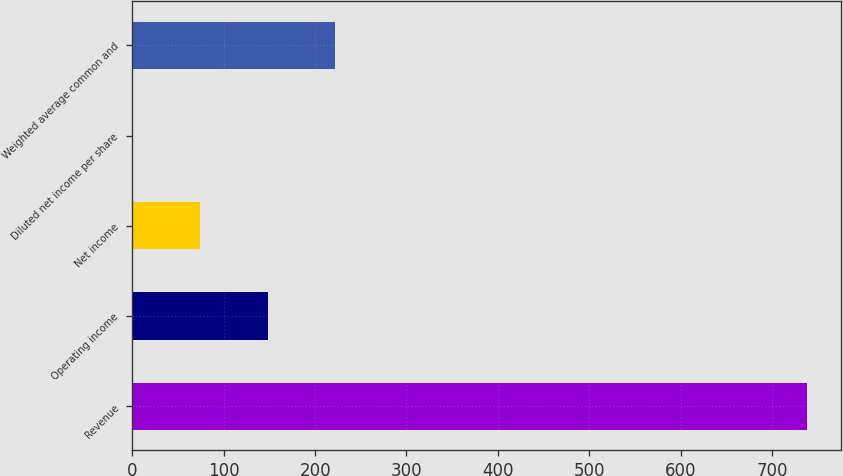<chart> <loc_0><loc_0><loc_500><loc_500><bar_chart><fcel>Revenue<fcel>Operating income<fcel>Net income<fcel>Diluted net income per share<fcel>Weighted average common and<nl><fcel>738.1<fcel>147.97<fcel>74.2<fcel>0.43<fcel>221.74<nl></chart> 